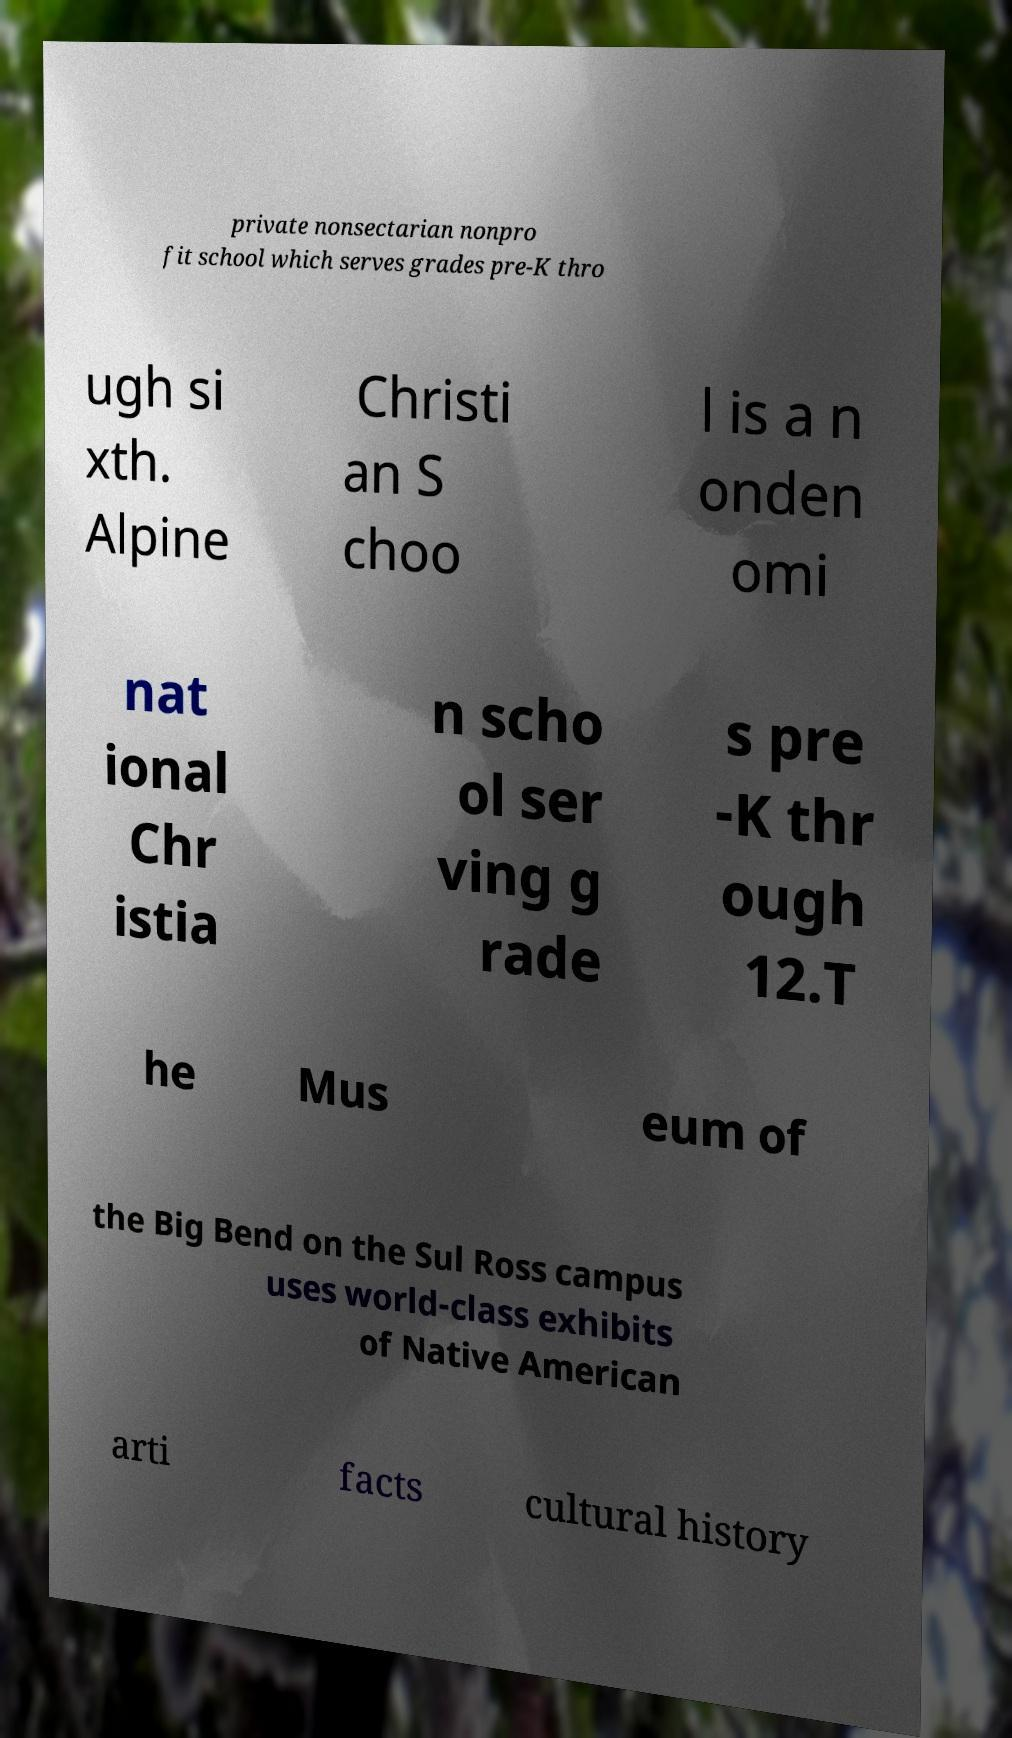Could you extract and type out the text from this image? private nonsectarian nonpro fit school which serves grades pre-K thro ugh si xth. Alpine Christi an S choo l is a n onden omi nat ional Chr istia n scho ol ser ving g rade s pre -K thr ough 12.T he Mus eum of the Big Bend on the Sul Ross campus uses world-class exhibits of Native American arti facts cultural history 